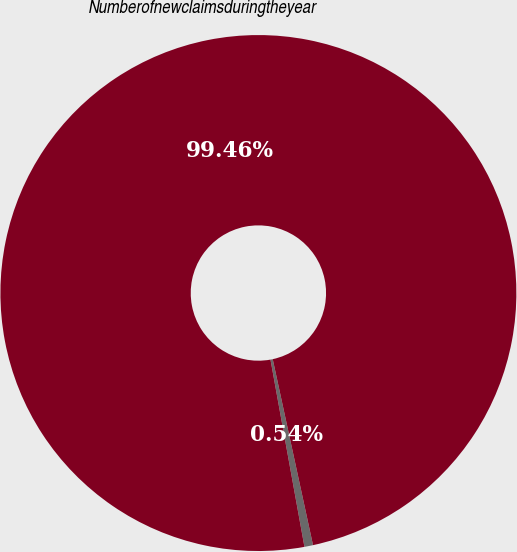<chart> <loc_0><loc_0><loc_500><loc_500><pie_chart><ecel><fcel>Numberofnewclaimsduringtheyear<nl><fcel>0.54%<fcel>99.46%<nl></chart> 